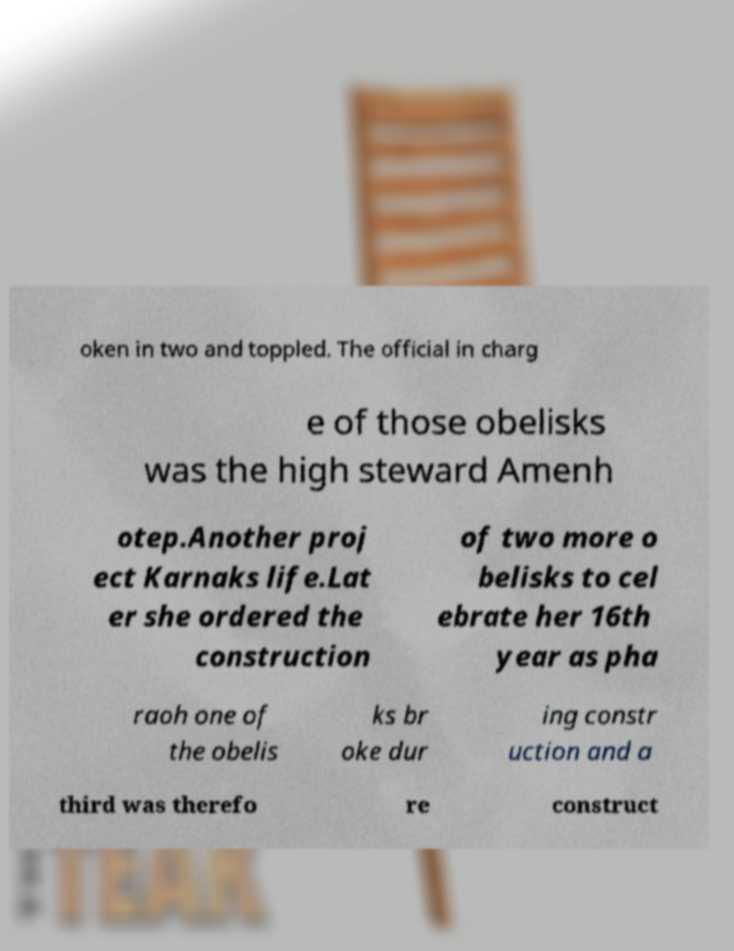Please identify and transcribe the text found in this image. oken in two and toppled. The official in charg e of those obelisks was the high steward Amenh otep.Another proj ect Karnaks life.Lat er she ordered the construction of two more o belisks to cel ebrate her 16th year as pha raoh one of the obelis ks br oke dur ing constr uction and a third was therefo re construct 